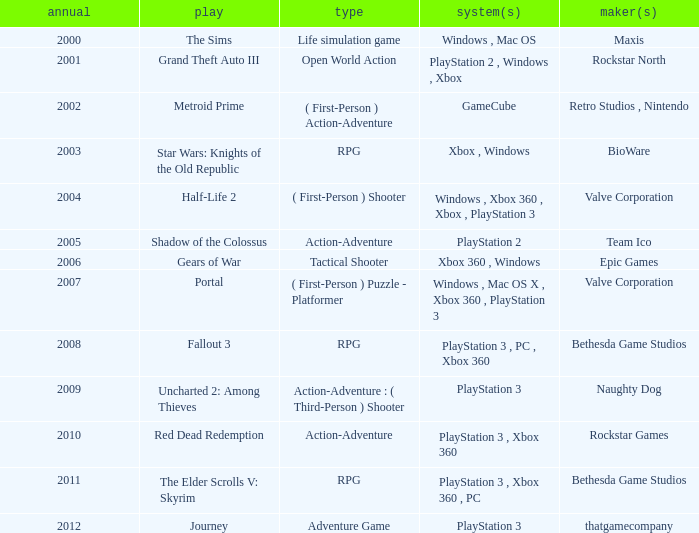What's the platform that has Rockstar Games as the developer? PlayStation 3 , Xbox 360. 